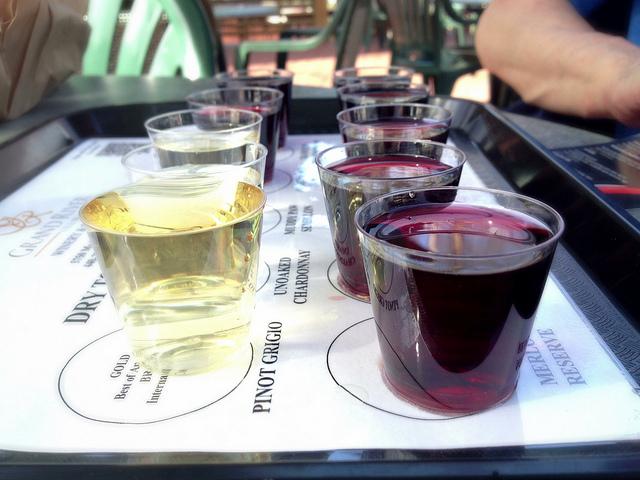Are the wine glasses full?
Give a very brief answer. Yes. Are all of the drinks the same?
Keep it brief. No. What are the people eating?
Be succinct. Wine. How many glasses are filled with drinks?
Concise answer only. 9. What does the writing on the mat indicate?
Keep it brief. Type of wine. 